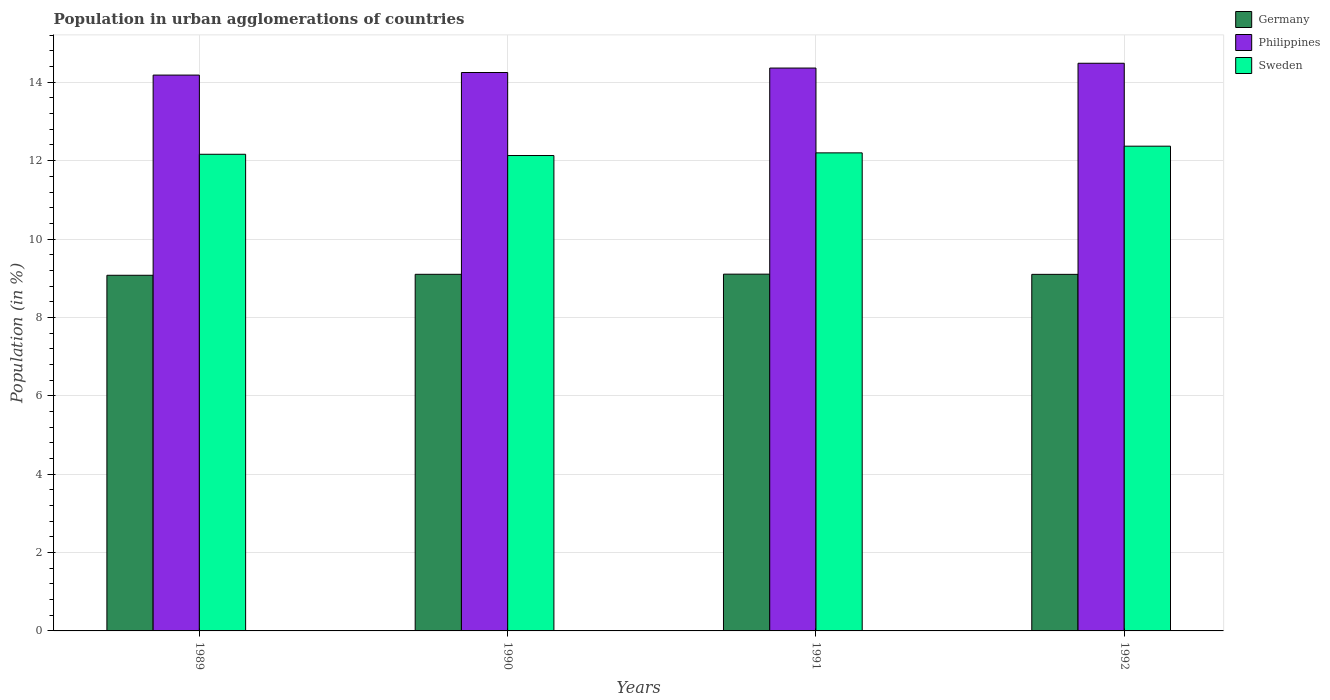How many different coloured bars are there?
Provide a short and direct response. 3. Are the number of bars per tick equal to the number of legend labels?
Provide a short and direct response. Yes. What is the percentage of population in urban agglomerations in Philippines in 1991?
Offer a terse response. 14.36. Across all years, what is the maximum percentage of population in urban agglomerations in Sweden?
Ensure brevity in your answer.  12.37. Across all years, what is the minimum percentage of population in urban agglomerations in Sweden?
Keep it short and to the point. 12.13. What is the total percentage of population in urban agglomerations in Philippines in the graph?
Provide a succinct answer. 57.28. What is the difference between the percentage of population in urban agglomerations in Germany in 1989 and that in 1992?
Offer a very short reply. -0.02. What is the difference between the percentage of population in urban agglomerations in Germany in 1991 and the percentage of population in urban agglomerations in Sweden in 1990?
Your response must be concise. -3.03. What is the average percentage of population in urban agglomerations in Philippines per year?
Your response must be concise. 14.32. In the year 1991, what is the difference between the percentage of population in urban agglomerations in Philippines and percentage of population in urban agglomerations in Germany?
Provide a succinct answer. 5.26. What is the ratio of the percentage of population in urban agglomerations in Philippines in 1991 to that in 1992?
Offer a very short reply. 0.99. Is the difference between the percentage of population in urban agglomerations in Philippines in 1990 and 1991 greater than the difference between the percentage of population in urban agglomerations in Germany in 1990 and 1991?
Ensure brevity in your answer.  No. What is the difference between the highest and the second highest percentage of population in urban agglomerations in Philippines?
Make the answer very short. 0.12. What is the difference between the highest and the lowest percentage of population in urban agglomerations in Philippines?
Make the answer very short. 0.3. Is the sum of the percentage of population in urban agglomerations in Sweden in 1990 and 1992 greater than the maximum percentage of population in urban agglomerations in Philippines across all years?
Provide a succinct answer. Yes. What does the 2nd bar from the left in 1990 represents?
Give a very brief answer. Philippines. Is it the case that in every year, the sum of the percentage of population in urban agglomerations in Germany and percentage of population in urban agglomerations in Philippines is greater than the percentage of population in urban agglomerations in Sweden?
Your answer should be compact. Yes. Are all the bars in the graph horizontal?
Your answer should be very brief. No. How many years are there in the graph?
Provide a succinct answer. 4. What is the difference between two consecutive major ticks on the Y-axis?
Ensure brevity in your answer.  2. Does the graph contain grids?
Offer a terse response. Yes. Where does the legend appear in the graph?
Provide a short and direct response. Top right. How many legend labels are there?
Make the answer very short. 3. How are the legend labels stacked?
Your answer should be compact. Vertical. What is the title of the graph?
Give a very brief answer. Population in urban agglomerations of countries. What is the label or title of the Y-axis?
Give a very brief answer. Population (in %). What is the Population (in %) of Germany in 1989?
Keep it short and to the point. 9.08. What is the Population (in %) of Philippines in 1989?
Give a very brief answer. 14.18. What is the Population (in %) in Sweden in 1989?
Make the answer very short. 12.16. What is the Population (in %) in Germany in 1990?
Offer a very short reply. 9.1. What is the Population (in %) of Philippines in 1990?
Ensure brevity in your answer.  14.25. What is the Population (in %) of Sweden in 1990?
Offer a very short reply. 12.13. What is the Population (in %) of Germany in 1991?
Offer a very short reply. 9.1. What is the Population (in %) in Philippines in 1991?
Provide a short and direct response. 14.36. What is the Population (in %) of Sweden in 1991?
Make the answer very short. 12.2. What is the Population (in %) in Germany in 1992?
Ensure brevity in your answer.  9.1. What is the Population (in %) of Philippines in 1992?
Keep it short and to the point. 14.49. What is the Population (in %) of Sweden in 1992?
Make the answer very short. 12.37. Across all years, what is the maximum Population (in %) of Germany?
Your answer should be compact. 9.1. Across all years, what is the maximum Population (in %) in Philippines?
Offer a very short reply. 14.49. Across all years, what is the maximum Population (in %) of Sweden?
Keep it short and to the point. 12.37. Across all years, what is the minimum Population (in %) in Germany?
Your response must be concise. 9.08. Across all years, what is the minimum Population (in %) of Philippines?
Your response must be concise. 14.18. Across all years, what is the minimum Population (in %) in Sweden?
Keep it short and to the point. 12.13. What is the total Population (in %) in Germany in the graph?
Provide a succinct answer. 36.38. What is the total Population (in %) in Philippines in the graph?
Your answer should be very brief. 57.28. What is the total Population (in %) of Sweden in the graph?
Your answer should be very brief. 48.86. What is the difference between the Population (in %) of Germany in 1989 and that in 1990?
Keep it short and to the point. -0.03. What is the difference between the Population (in %) in Philippines in 1989 and that in 1990?
Offer a very short reply. -0.07. What is the difference between the Population (in %) of Sweden in 1989 and that in 1990?
Give a very brief answer. 0.03. What is the difference between the Population (in %) of Germany in 1989 and that in 1991?
Offer a very short reply. -0.03. What is the difference between the Population (in %) of Philippines in 1989 and that in 1991?
Your answer should be compact. -0.18. What is the difference between the Population (in %) in Sweden in 1989 and that in 1991?
Your answer should be very brief. -0.04. What is the difference between the Population (in %) of Germany in 1989 and that in 1992?
Your answer should be very brief. -0.02. What is the difference between the Population (in %) of Philippines in 1989 and that in 1992?
Make the answer very short. -0.3. What is the difference between the Population (in %) of Sweden in 1989 and that in 1992?
Offer a very short reply. -0.21. What is the difference between the Population (in %) in Germany in 1990 and that in 1991?
Make the answer very short. -0. What is the difference between the Population (in %) in Philippines in 1990 and that in 1991?
Make the answer very short. -0.11. What is the difference between the Population (in %) in Sweden in 1990 and that in 1991?
Provide a short and direct response. -0.07. What is the difference between the Population (in %) in Germany in 1990 and that in 1992?
Offer a terse response. 0. What is the difference between the Population (in %) of Philippines in 1990 and that in 1992?
Provide a succinct answer. -0.24. What is the difference between the Population (in %) of Sweden in 1990 and that in 1992?
Give a very brief answer. -0.24. What is the difference between the Population (in %) of Germany in 1991 and that in 1992?
Make the answer very short. 0.01. What is the difference between the Population (in %) in Philippines in 1991 and that in 1992?
Provide a short and direct response. -0.12. What is the difference between the Population (in %) of Sweden in 1991 and that in 1992?
Offer a terse response. -0.17. What is the difference between the Population (in %) in Germany in 1989 and the Population (in %) in Philippines in 1990?
Make the answer very short. -5.17. What is the difference between the Population (in %) of Germany in 1989 and the Population (in %) of Sweden in 1990?
Give a very brief answer. -3.06. What is the difference between the Population (in %) of Philippines in 1989 and the Population (in %) of Sweden in 1990?
Keep it short and to the point. 2.05. What is the difference between the Population (in %) in Germany in 1989 and the Population (in %) in Philippines in 1991?
Keep it short and to the point. -5.29. What is the difference between the Population (in %) of Germany in 1989 and the Population (in %) of Sweden in 1991?
Keep it short and to the point. -3.12. What is the difference between the Population (in %) in Philippines in 1989 and the Population (in %) in Sweden in 1991?
Provide a short and direct response. 1.99. What is the difference between the Population (in %) in Germany in 1989 and the Population (in %) in Philippines in 1992?
Give a very brief answer. -5.41. What is the difference between the Population (in %) of Germany in 1989 and the Population (in %) of Sweden in 1992?
Offer a terse response. -3.29. What is the difference between the Population (in %) of Philippines in 1989 and the Population (in %) of Sweden in 1992?
Ensure brevity in your answer.  1.81. What is the difference between the Population (in %) of Germany in 1990 and the Population (in %) of Philippines in 1991?
Your response must be concise. -5.26. What is the difference between the Population (in %) of Germany in 1990 and the Population (in %) of Sweden in 1991?
Your answer should be compact. -3.1. What is the difference between the Population (in %) of Philippines in 1990 and the Population (in %) of Sweden in 1991?
Your response must be concise. 2.05. What is the difference between the Population (in %) in Germany in 1990 and the Population (in %) in Philippines in 1992?
Your answer should be very brief. -5.39. What is the difference between the Population (in %) of Germany in 1990 and the Population (in %) of Sweden in 1992?
Your answer should be compact. -3.27. What is the difference between the Population (in %) in Philippines in 1990 and the Population (in %) in Sweden in 1992?
Your answer should be very brief. 1.88. What is the difference between the Population (in %) of Germany in 1991 and the Population (in %) of Philippines in 1992?
Your answer should be compact. -5.38. What is the difference between the Population (in %) in Germany in 1991 and the Population (in %) in Sweden in 1992?
Your answer should be very brief. -3.27. What is the difference between the Population (in %) in Philippines in 1991 and the Population (in %) in Sweden in 1992?
Provide a succinct answer. 1.99. What is the average Population (in %) in Germany per year?
Keep it short and to the point. 9.09. What is the average Population (in %) of Philippines per year?
Ensure brevity in your answer.  14.32. What is the average Population (in %) in Sweden per year?
Your response must be concise. 12.22. In the year 1989, what is the difference between the Population (in %) in Germany and Population (in %) in Philippines?
Your answer should be compact. -5.11. In the year 1989, what is the difference between the Population (in %) in Germany and Population (in %) in Sweden?
Your answer should be compact. -3.09. In the year 1989, what is the difference between the Population (in %) in Philippines and Population (in %) in Sweden?
Offer a terse response. 2.02. In the year 1990, what is the difference between the Population (in %) in Germany and Population (in %) in Philippines?
Offer a very short reply. -5.15. In the year 1990, what is the difference between the Population (in %) of Germany and Population (in %) of Sweden?
Provide a short and direct response. -3.03. In the year 1990, what is the difference between the Population (in %) of Philippines and Population (in %) of Sweden?
Provide a short and direct response. 2.12. In the year 1991, what is the difference between the Population (in %) in Germany and Population (in %) in Philippines?
Offer a very short reply. -5.26. In the year 1991, what is the difference between the Population (in %) in Germany and Population (in %) in Sweden?
Provide a succinct answer. -3.09. In the year 1991, what is the difference between the Population (in %) in Philippines and Population (in %) in Sweden?
Give a very brief answer. 2.16. In the year 1992, what is the difference between the Population (in %) in Germany and Population (in %) in Philippines?
Keep it short and to the point. -5.39. In the year 1992, what is the difference between the Population (in %) in Germany and Population (in %) in Sweden?
Your answer should be compact. -3.27. In the year 1992, what is the difference between the Population (in %) in Philippines and Population (in %) in Sweden?
Provide a succinct answer. 2.12. What is the ratio of the Population (in %) of Germany in 1989 to that in 1990?
Your response must be concise. 1. What is the ratio of the Population (in %) in Philippines in 1989 to that in 1990?
Make the answer very short. 1. What is the ratio of the Population (in %) in Sweden in 1989 to that in 1990?
Your answer should be compact. 1. What is the ratio of the Population (in %) of Philippines in 1989 to that in 1991?
Your response must be concise. 0.99. What is the ratio of the Population (in %) of Sweden in 1989 to that in 1991?
Give a very brief answer. 1. What is the ratio of the Population (in %) of Germany in 1989 to that in 1992?
Offer a terse response. 1. What is the ratio of the Population (in %) of Philippines in 1989 to that in 1992?
Ensure brevity in your answer.  0.98. What is the ratio of the Population (in %) of Sweden in 1989 to that in 1992?
Offer a terse response. 0.98. What is the ratio of the Population (in %) of Germany in 1990 to that in 1991?
Your answer should be compact. 1. What is the ratio of the Population (in %) in Philippines in 1990 to that in 1991?
Offer a very short reply. 0.99. What is the ratio of the Population (in %) in Germany in 1990 to that in 1992?
Offer a terse response. 1. What is the ratio of the Population (in %) in Philippines in 1990 to that in 1992?
Provide a short and direct response. 0.98. What is the ratio of the Population (in %) of Sweden in 1990 to that in 1992?
Your answer should be compact. 0.98. What is the ratio of the Population (in %) of Germany in 1991 to that in 1992?
Your answer should be compact. 1. What is the ratio of the Population (in %) of Sweden in 1991 to that in 1992?
Your response must be concise. 0.99. What is the difference between the highest and the second highest Population (in %) in Germany?
Your answer should be compact. 0. What is the difference between the highest and the second highest Population (in %) in Philippines?
Your response must be concise. 0.12. What is the difference between the highest and the second highest Population (in %) of Sweden?
Make the answer very short. 0.17. What is the difference between the highest and the lowest Population (in %) of Germany?
Offer a very short reply. 0.03. What is the difference between the highest and the lowest Population (in %) of Philippines?
Provide a short and direct response. 0.3. What is the difference between the highest and the lowest Population (in %) of Sweden?
Make the answer very short. 0.24. 